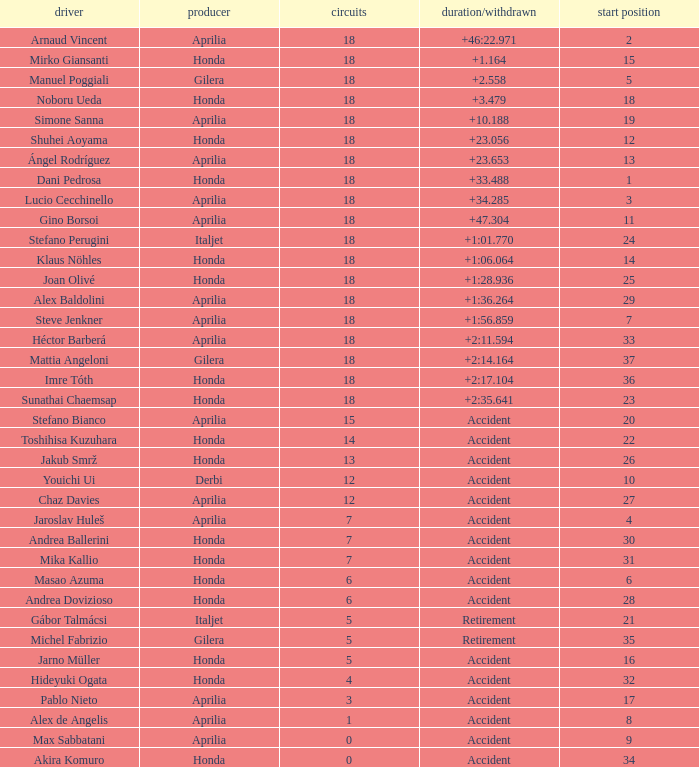What is the time/retired of the honda manufacturer with a grid less than 26, 18 laps, and joan olivé as the rider? +1:28.936. 